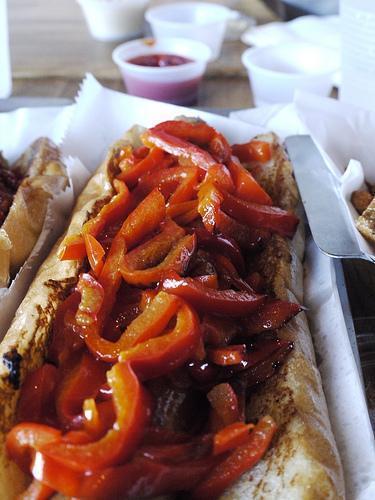How many italian sausages are fully visible?
Give a very brief answer. 1. 